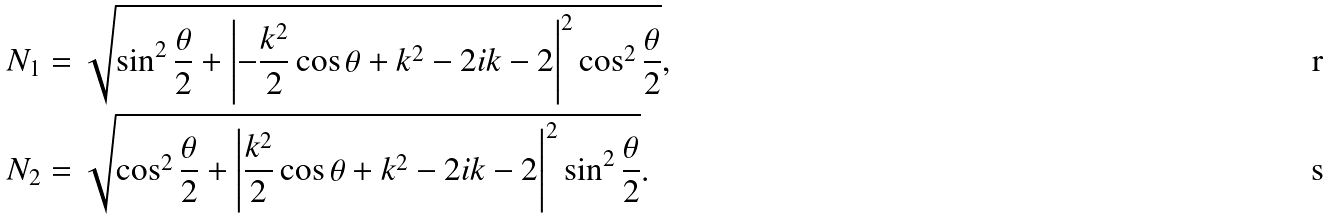<formula> <loc_0><loc_0><loc_500><loc_500>N _ { 1 } & = \sqrt { \sin ^ { 2 } \frac { \theta } { 2 } + \left | - \frac { k ^ { 2 } } { 2 } \cos \theta + k ^ { 2 } - 2 i k - 2 \right | ^ { 2 } \cos ^ { 2 } \frac { \theta } { 2 } } , \\ N _ { 2 } & = \sqrt { \cos ^ { 2 } \frac { \theta } { 2 } + \left | \frac { k ^ { 2 } } { 2 } \cos \theta + k ^ { 2 } - 2 i k - 2 \right | ^ { 2 } \sin ^ { 2 } \frac { \theta } { 2 } } .</formula> 